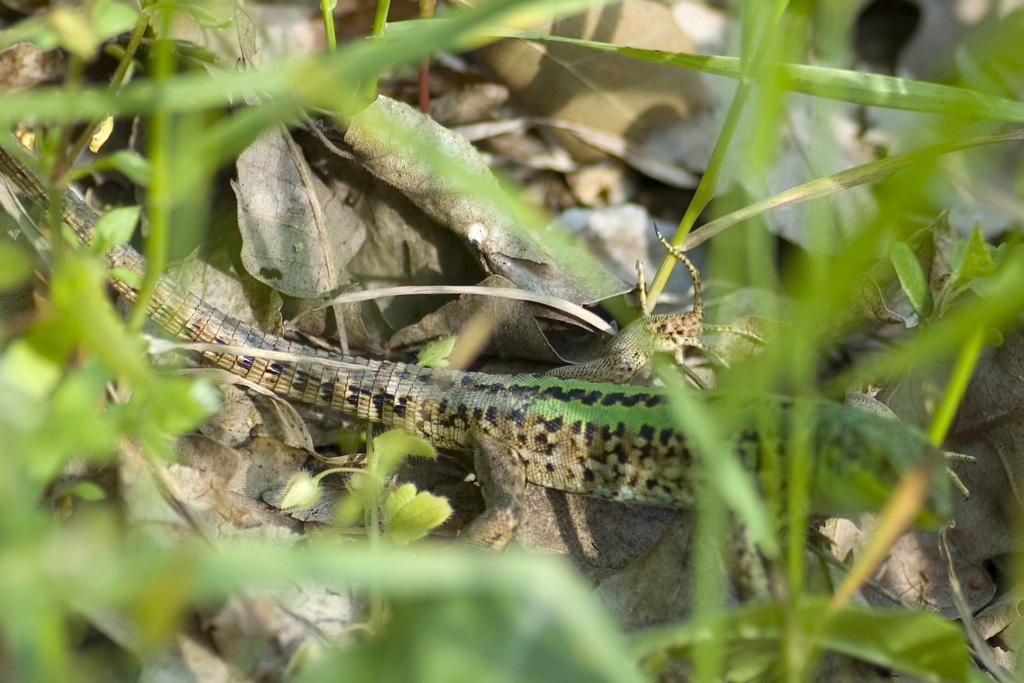What type of animal can be seen in the image? There is a snake in the image. What other living organisms are present in the image? There are plants in the image. What can be found on the ground in the image? Leaves are present on the ground in the image. What type of grape is being traded in the image? There is no grape or trade activity present in the image; it features a snake and plants. 